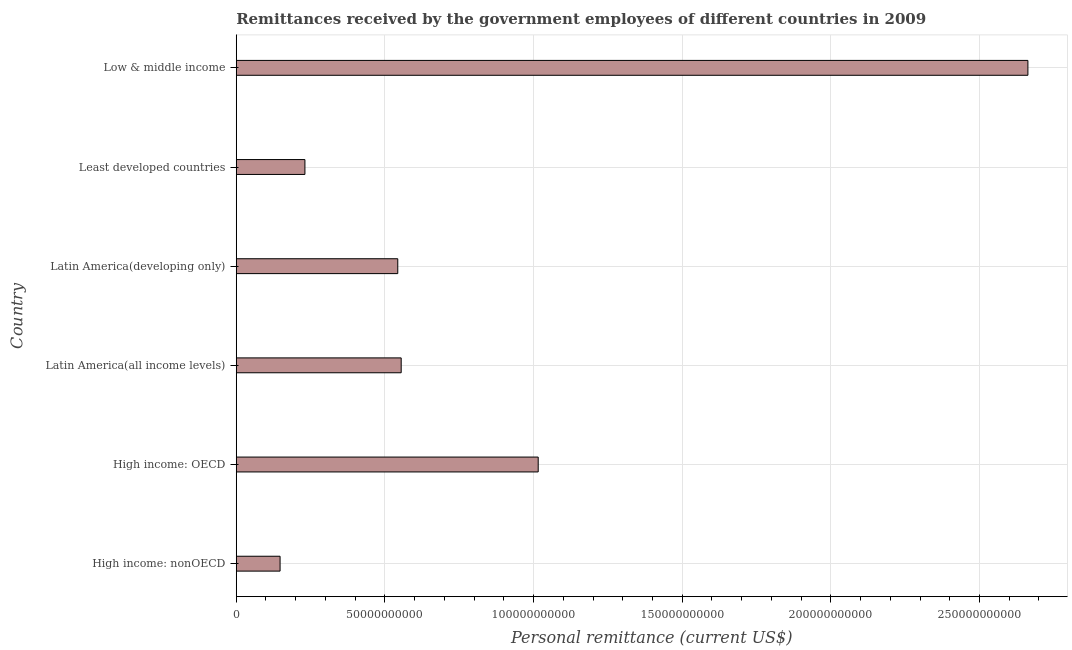Does the graph contain any zero values?
Make the answer very short. No. What is the title of the graph?
Keep it short and to the point. Remittances received by the government employees of different countries in 2009. What is the label or title of the X-axis?
Your response must be concise. Personal remittance (current US$). What is the label or title of the Y-axis?
Offer a very short reply. Country. What is the personal remittances in Least developed countries?
Your response must be concise. 2.31e+1. Across all countries, what is the maximum personal remittances?
Give a very brief answer. 2.66e+11. Across all countries, what is the minimum personal remittances?
Offer a very short reply. 1.47e+1. In which country was the personal remittances minimum?
Provide a short and direct response. High income: nonOECD. What is the sum of the personal remittances?
Your answer should be very brief. 5.15e+11. What is the difference between the personal remittances in High income: nonOECD and Latin America(developing only)?
Provide a short and direct response. -3.96e+1. What is the average personal remittances per country?
Your answer should be compact. 8.59e+1. What is the median personal remittances?
Provide a short and direct response. 5.49e+1. What is the ratio of the personal remittances in High income: OECD to that in Least developed countries?
Offer a terse response. 4.4. What is the difference between the highest and the second highest personal remittances?
Provide a short and direct response. 1.65e+11. Is the sum of the personal remittances in High income: OECD and Latin America(developing only) greater than the maximum personal remittances across all countries?
Ensure brevity in your answer.  No. What is the difference between the highest and the lowest personal remittances?
Keep it short and to the point. 2.52e+11. Are all the bars in the graph horizontal?
Make the answer very short. Yes. How many countries are there in the graph?
Provide a short and direct response. 6. What is the difference between two consecutive major ticks on the X-axis?
Your response must be concise. 5.00e+1. What is the Personal remittance (current US$) of High income: nonOECD?
Offer a very short reply. 1.47e+1. What is the Personal remittance (current US$) of High income: OECD?
Make the answer very short. 1.02e+11. What is the Personal remittance (current US$) in Latin America(all income levels)?
Your answer should be compact. 5.55e+1. What is the Personal remittance (current US$) of Latin America(developing only)?
Offer a very short reply. 5.43e+1. What is the Personal remittance (current US$) in Least developed countries?
Offer a terse response. 2.31e+1. What is the Personal remittance (current US$) in Low & middle income?
Make the answer very short. 2.66e+11. What is the difference between the Personal remittance (current US$) in High income: nonOECD and High income: OECD?
Offer a terse response. -8.68e+1. What is the difference between the Personal remittance (current US$) in High income: nonOECD and Latin America(all income levels)?
Offer a very short reply. -4.07e+1. What is the difference between the Personal remittance (current US$) in High income: nonOECD and Latin America(developing only)?
Your answer should be compact. -3.96e+1. What is the difference between the Personal remittance (current US$) in High income: nonOECD and Least developed countries?
Your response must be concise. -8.36e+09. What is the difference between the Personal remittance (current US$) in High income: nonOECD and Low & middle income?
Keep it short and to the point. -2.52e+11. What is the difference between the Personal remittance (current US$) in High income: OECD and Latin America(all income levels)?
Keep it short and to the point. 4.61e+1. What is the difference between the Personal remittance (current US$) in High income: OECD and Latin America(developing only)?
Offer a terse response. 4.72e+1. What is the difference between the Personal remittance (current US$) in High income: OECD and Least developed countries?
Make the answer very short. 7.85e+1. What is the difference between the Personal remittance (current US$) in High income: OECD and Low & middle income?
Your answer should be very brief. -1.65e+11. What is the difference between the Personal remittance (current US$) in Latin America(all income levels) and Latin America(developing only)?
Your response must be concise. 1.15e+09. What is the difference between the Personal remittance (current US$) in Latin America(all income levels) and Least developed countries?
Your answer should be very brief. 3.24e+1. What is the difference between the Personal remittance (current US$) in Latin America(all income levels) and Low & middle income?
Your answer should be very brief. -2.11e+11. What is the difference between the Personal remittance (current US$) in Latin America(developing only) and Least developed countries?
Ensure brevity in your answer.  3.12e+1. What is the difference between the Personal remittance (current US$) in Latin America(developing only) and Low & middle income?
Offer a very short reply. -2.12e+11. What is the difference between the Personal remittance (current US$) in Least developed countries and Low & middle income?
Provide a succinct answer. -2.43e+11. What is the ratio of the Personal remittance (current US$) in High income: nonOECD to that in High income: OECD?
Provide a succinct answer. 0.14. What is the ratio of the Personal remittance (current US$) in High income: nonOECD to that in Latin America(all income levels)?
Keep it short and to the point. 0.27. What is the ratio of the Personal remittance (current US$) in High income: nonOECD to that in Latin America(developing only)?
Offer a very short reply. 0.27. What is the ratio of the Personal remittance (current US$) in High income: nonOECD to that in Least developed countries?
Keep it short and to the point. 0.64. What is the ratio of the Personal remittance (current US$) in High income: nonOECD to that in Low & middle income?
Provide a succinct answer. 0.06. What is the ratio of the Personal remittance (current US$) in High income: OECD to that in Latin America(all income levels)?
Give a very brief answer. 1.83. What is the ratio of the Personal remittance (current US$) in High income: OECD to that in Latin America(developing only)?
Your answer should be very brief. 1.87. What is the ratio of the Personal remittance (current US$) in High income: OECD to that in Least developed countries?
Your answer should be very brief. 4.4. What is the ratio of the Personal remittance (current US$) in High income: OECD to that in Low & middle income?
Provide a succinct answer. 0.38. What is the ratio of the Personal remittance (current US$) in Latin America(all income levels) to that in Least developed countries?
Give a very brief answer. 2.4. What is the ratio of the Personal remittance (current US$) in Latin America(all income levels) to that in Low & middle income?
Your answer should be very brief. 0.21. What is the ratio of the Personal remittance (current US$) in Latin America(developing only) to that in Least developed countries?
Offer a terse response. 2.35. What is the ratio of the Personal remittance (current US$) in Latin America(developing only) to that in Low & middle income?
Your answer should be compact. 0.2. What is the ratio of the Personal remittance (current US$) in Least developed countries to that in Low & middle income?
Offer a very short reply. 0.09. 